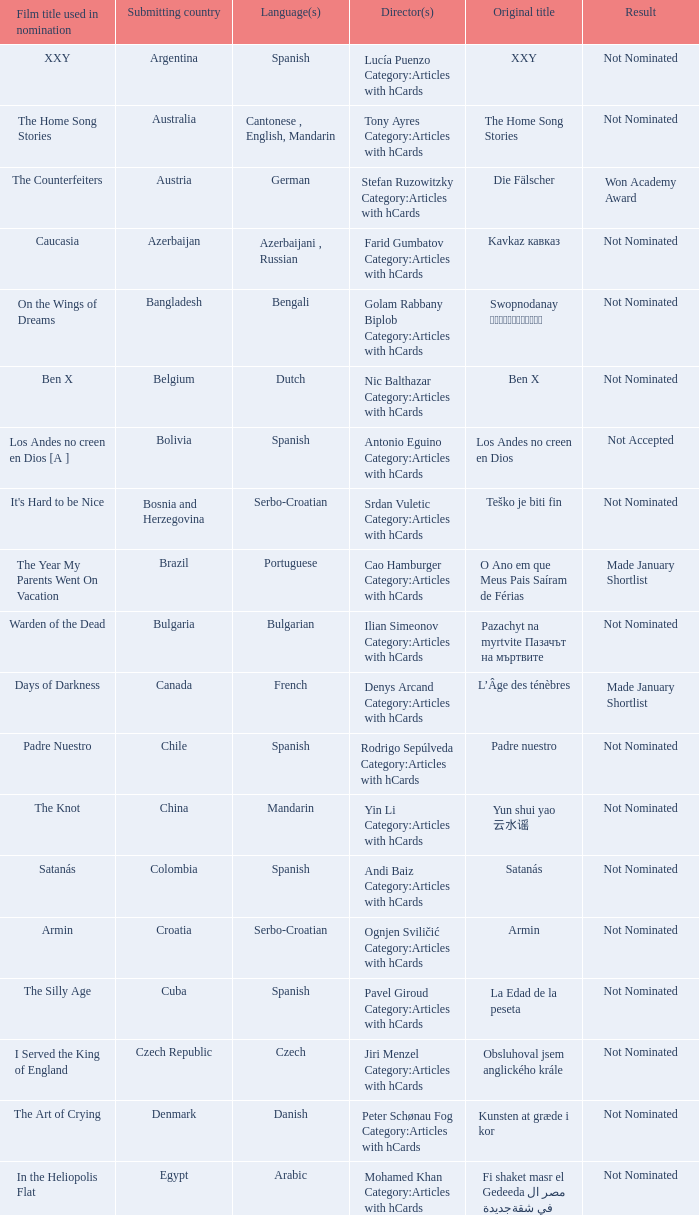What country submitted miehen työ? Finland. 